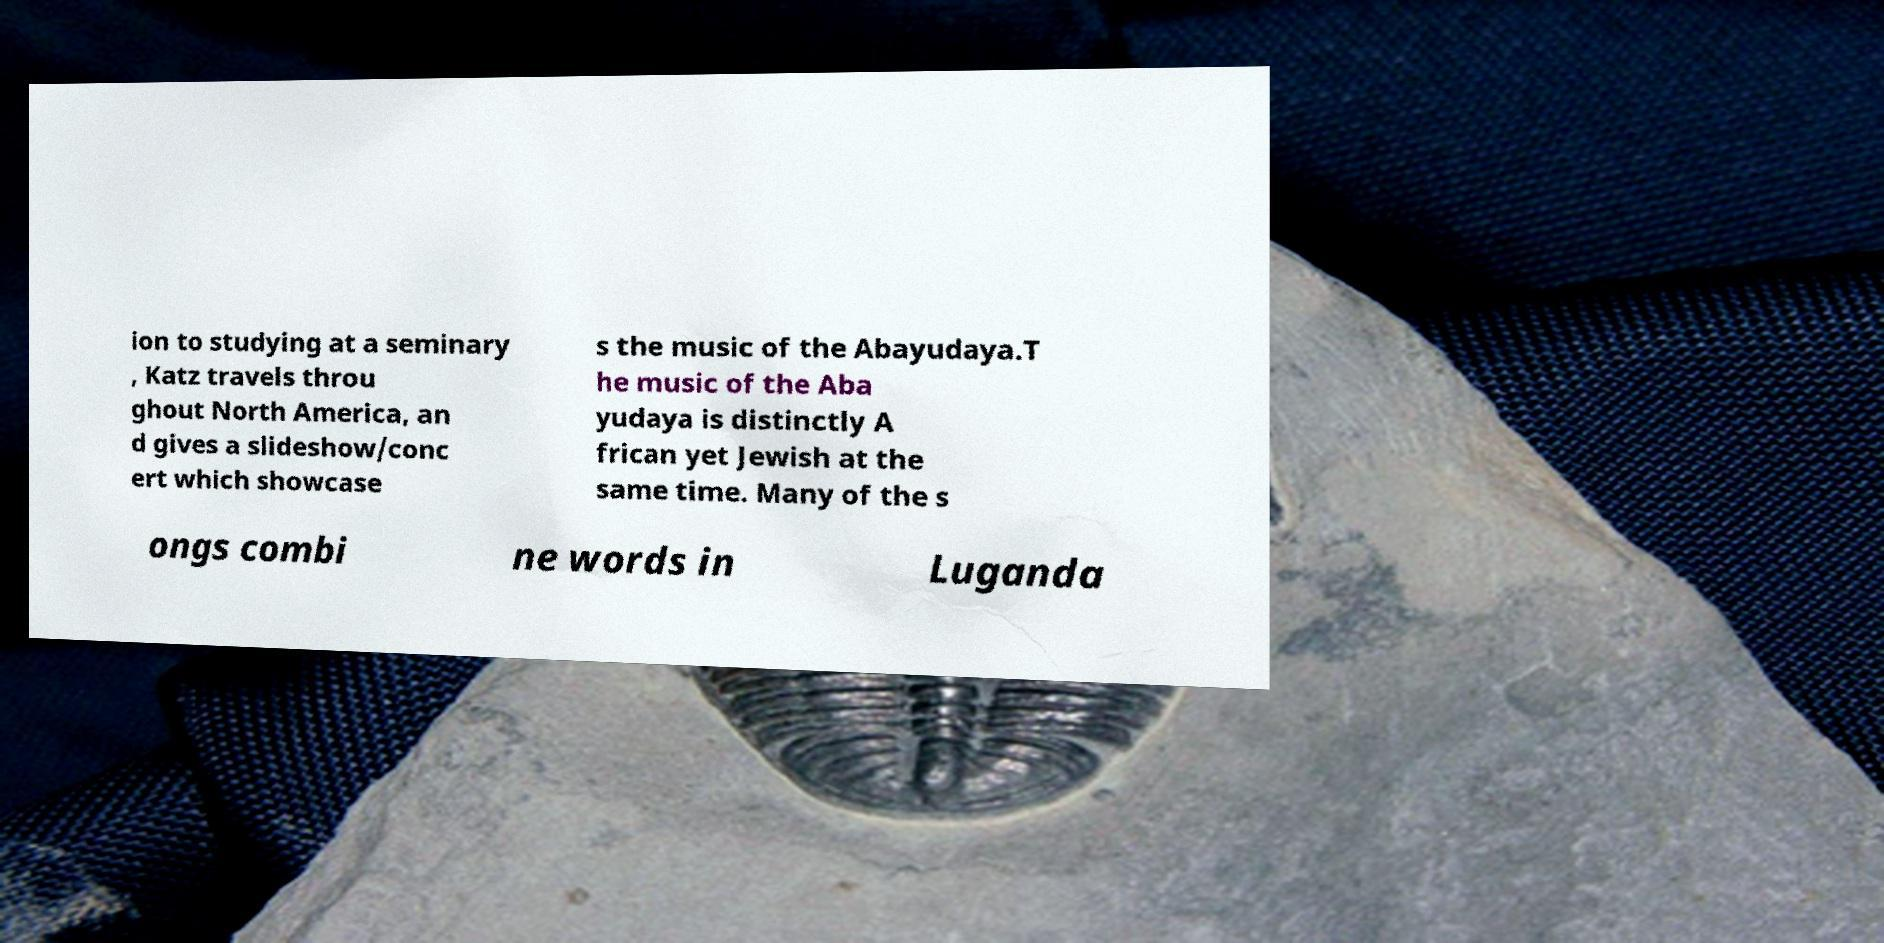Could you extract and type out the text from this image? ion to studying at a seminary , Katz travels throu ghout North America, an d gives a slideshow/conc ert which showcase s the music of the Abayudaya.T he music of the Aba yudaya is distinctly A frican yet Jewish at the same time. Many of the s ongs combi ne words in Luganda 